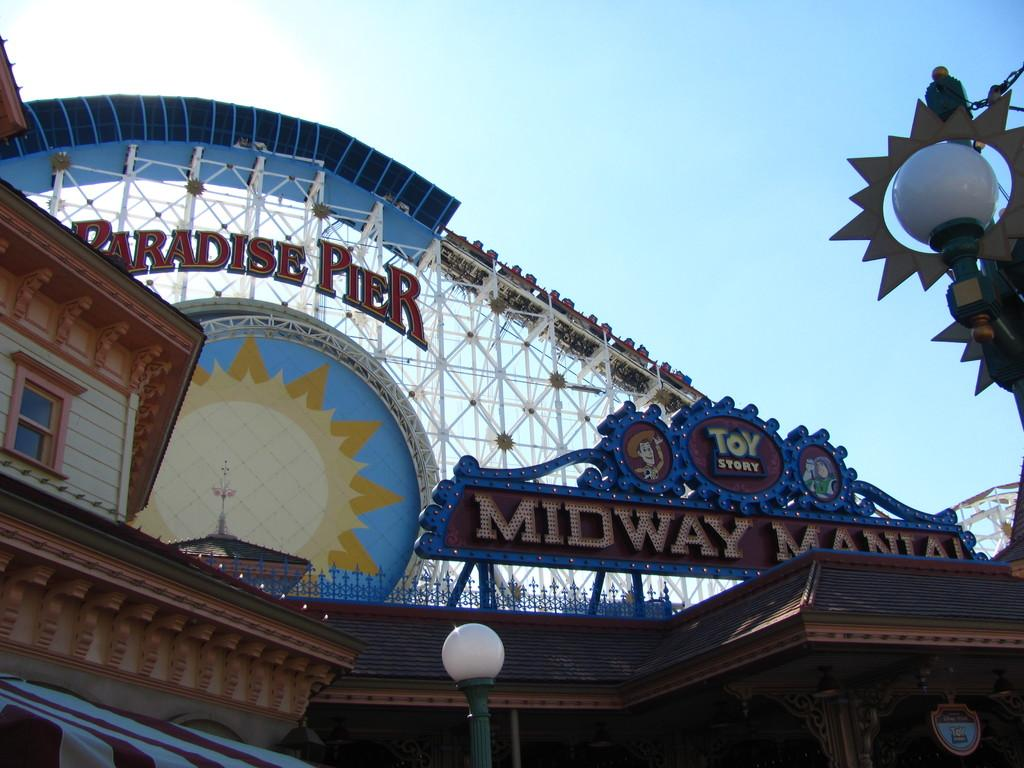<image>
Offer a succinct explanation of the picture presented. Paradise pier has a toy story roller coaster ride 